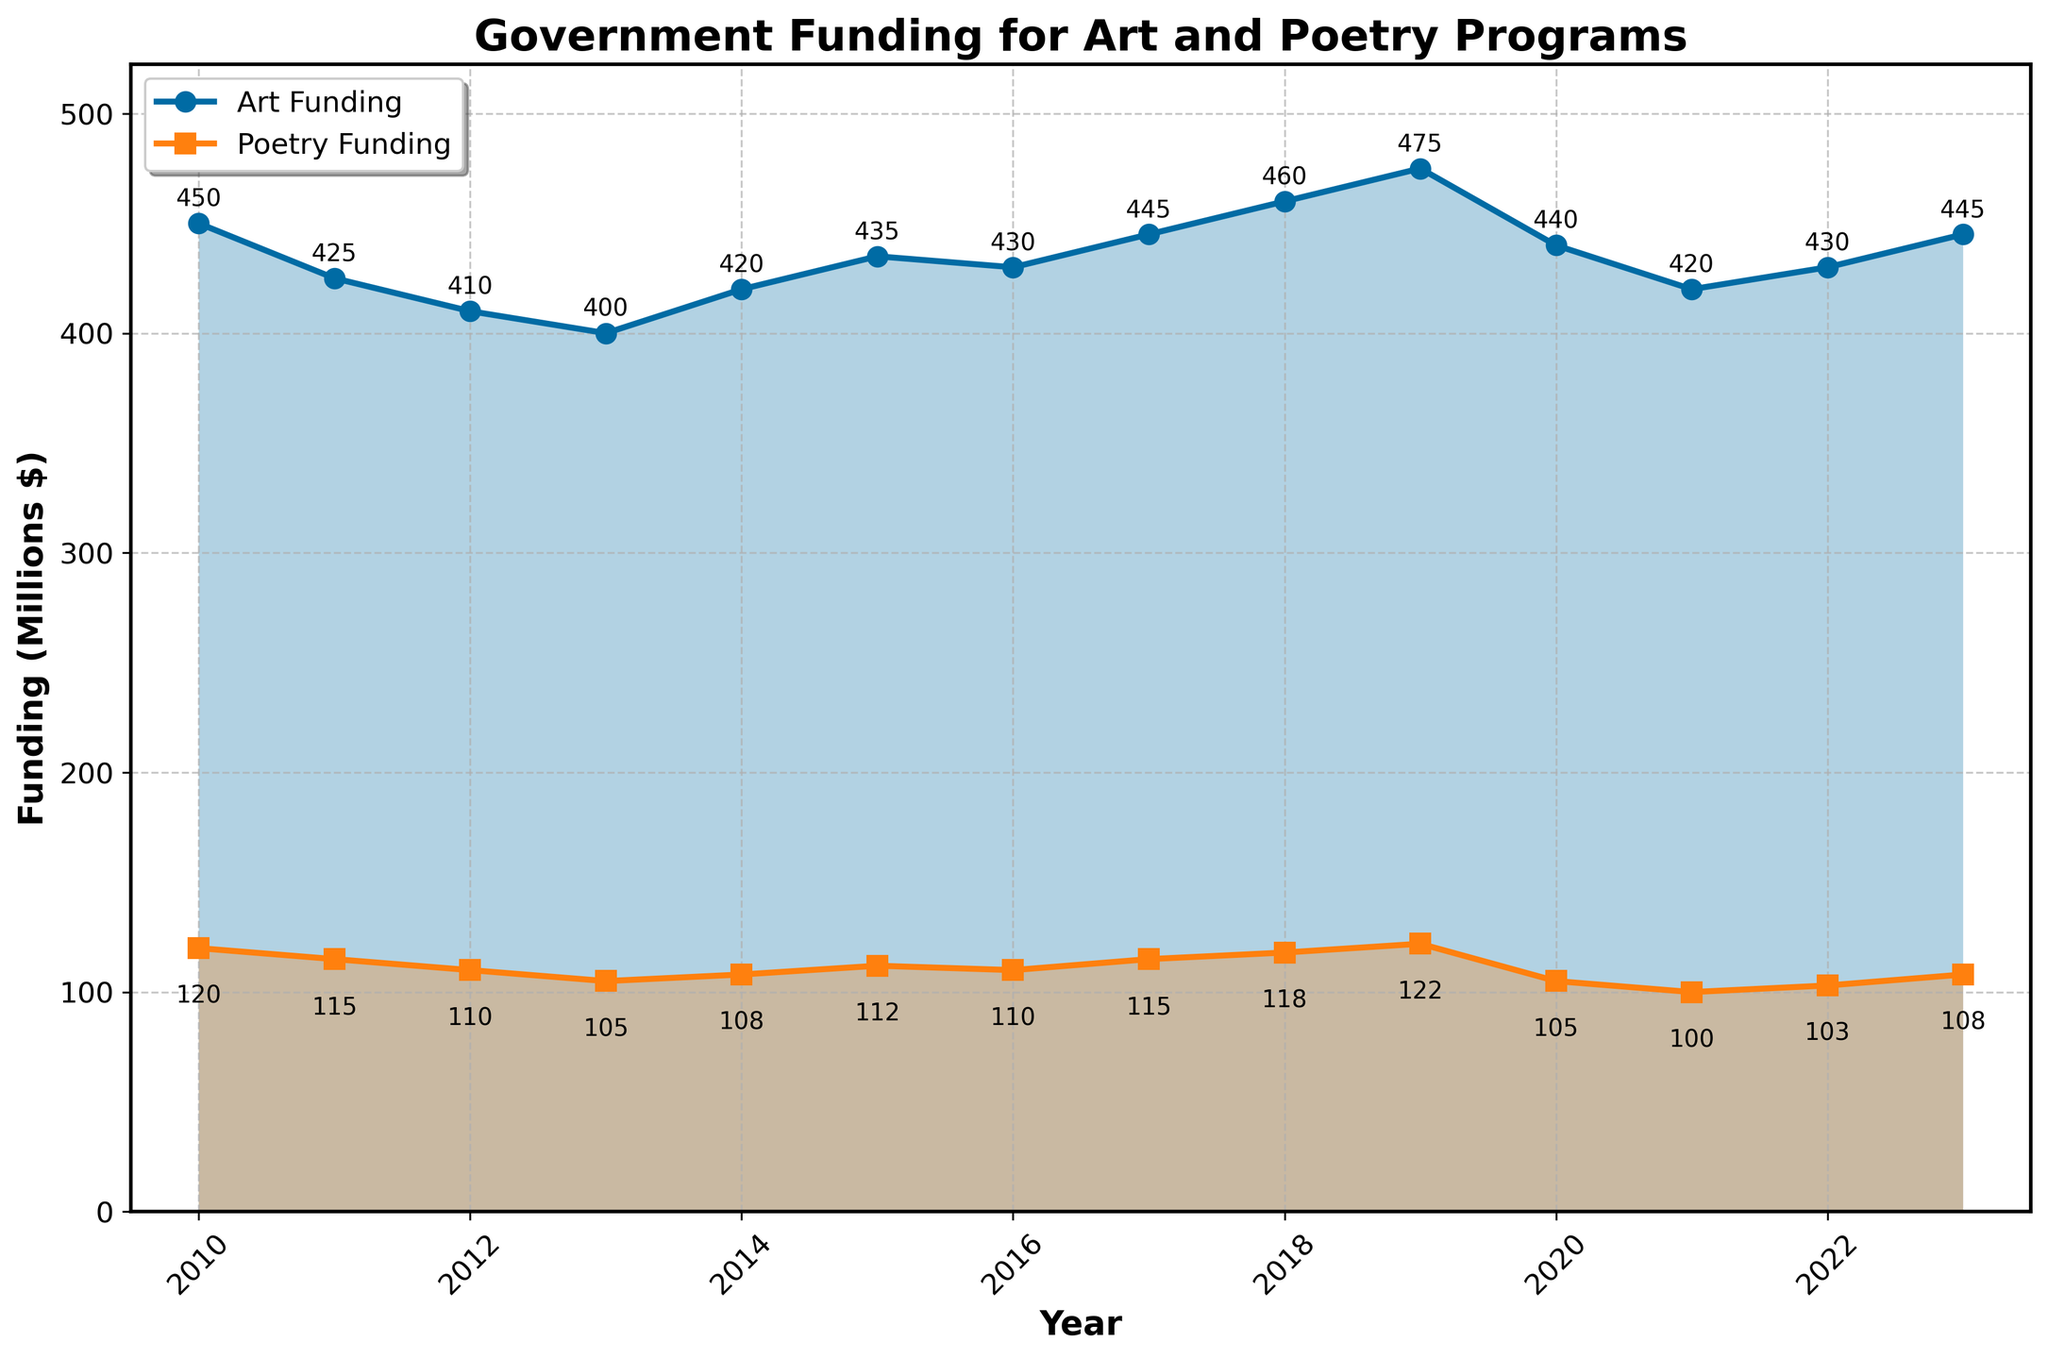What trend can you observe in art funding between 2010 and 2023? Observe the line representing art funding on the line chart. It starts at a high point in 2010, declines gradually until 2014, then shows some fluctuations with occasional increases. Overall, it has a downward trend with slight recovery in recent years.
Answer: General decrease with fluctuations How did poetry funding change from 2010 to 2023? Look at the line representing poetry funding. It shows a steady decline from 2010 until around 2014, a slight recovery until 2019, followed by another decline and smaller increases toward 2023.
Answer: Steady decline with slight recoveries and more decline Which year observed the highest funding for art, and how much was it? Find the highest point on the line chart representing art funding. The peak funding is in 2019 with the corresponding value annotated on the graph.
Answer: 2019, $475M In which year was the difference between art and poetry funding the smallest? Determine the difference between the two lines year by year and identify the smallest gap. The differences are smallest when the lines are closest.
Answer: 2017 Calculate the average art funding from 2010 to 2023. Identify the art funding values given for each year, sum them, and divide by the total number of years. Sum = 450 + 425 + 410 + 400 + 420 + 435 + 430 + 445 + 460 + 475 + 440 + 420 + 430 + 445. Number of years = 14. Average = Sum / 14.
Answer: $436.43M In 2020, did art or poetry funding experience a larger drop compared to 2019? Compare the values annotated for 2019 and 2020 in both lines. For art: 475 (2019) - 440 (2020). For poetry: 122 (2019) - 105 (2020). The larger drop is the one with the higher numeric value.
Answer: Art funding What visual attribute helps you identify the continuity of the funding trends over the years? Recognize elements such as the continuous lines, shaded areas, and markers that show progression over time without gaps. These visual cues indicate trends and allow tracking changes year by year.
Answer: Continuous lines and shaded areas Compare the funding trends in 2013 for both art and poetry. Look at the lines and values for the year 2013. Both art and poetry funding decrease in 2013, with art at $400M and poetry at $105M, indicating both experienced reduction.
Answer: Both decreased In 2023, how much higher is art funding compared to poetry funding? Check the values annotated for 2023. Art funding = $445M, Poetry funding = $108M. Subtract poetry funding from art funding to find the difference (445 - 108).
Answer: $337M Determine the year when poetry funding was at its lowest and provide the funding amount. Identify the lowest point on the poetry funding line and note the corresponding year and funding amount. The lowest point can be found at 2021 with annotation.
Answer: 2021, $100M 